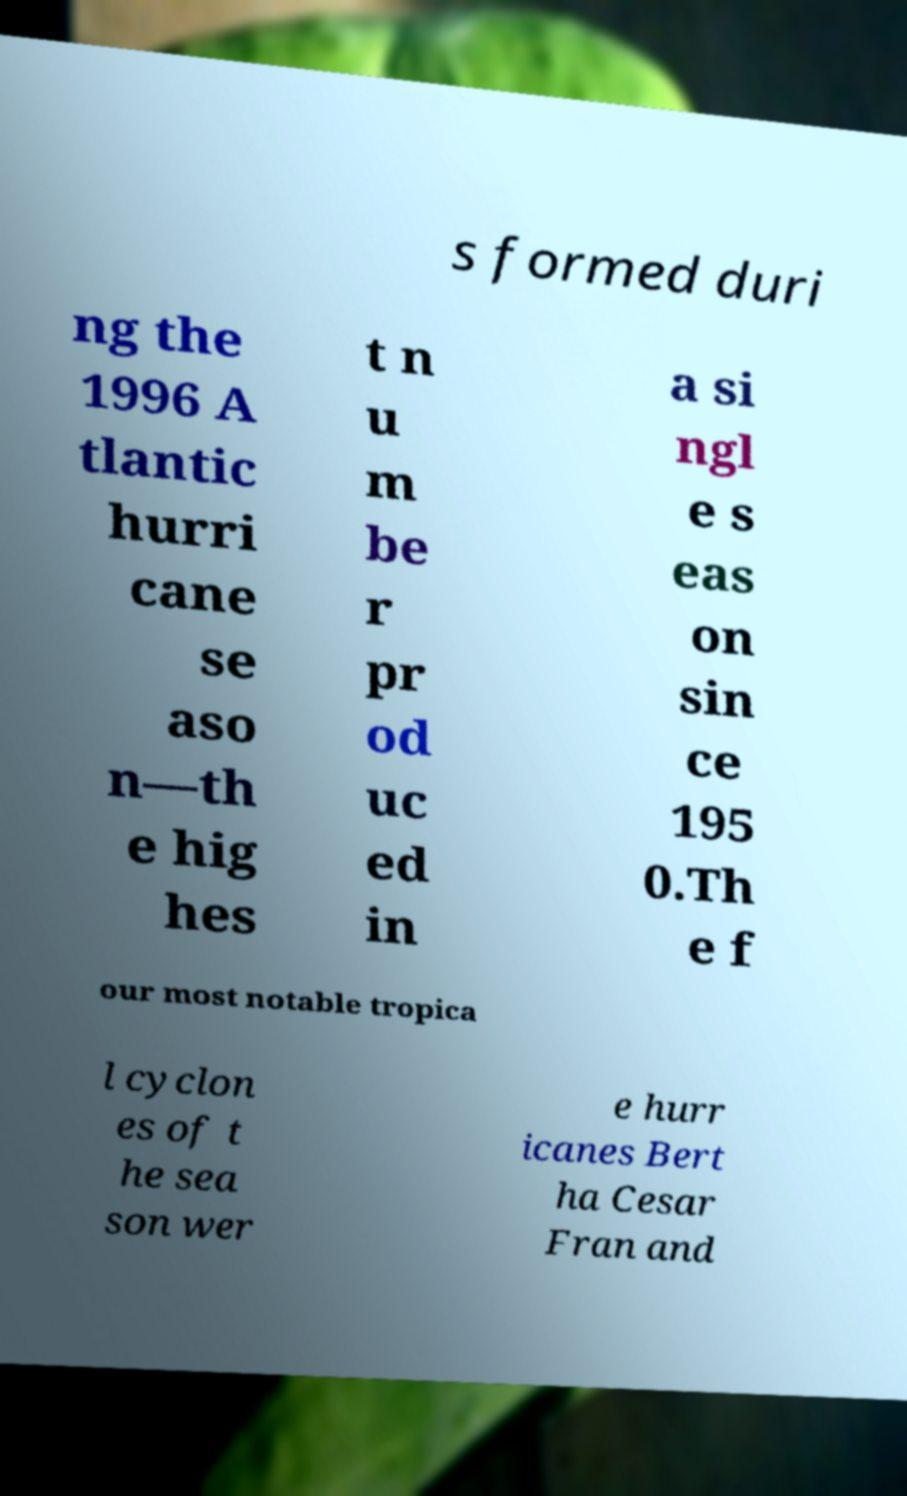There's text embedded in this image that I need extracted. Can you transcribe it verbatim? s formed duri ng the 1996 A tlantic hurri cane se aso n—th e hig hes t n u m be r pr od uc ed in a si ngl e s eas on sin ce 195 0.Th e f our most notable tropica l cyclon es of t he sea son wer e hurr icanes Bert ha Cesar Fran and 